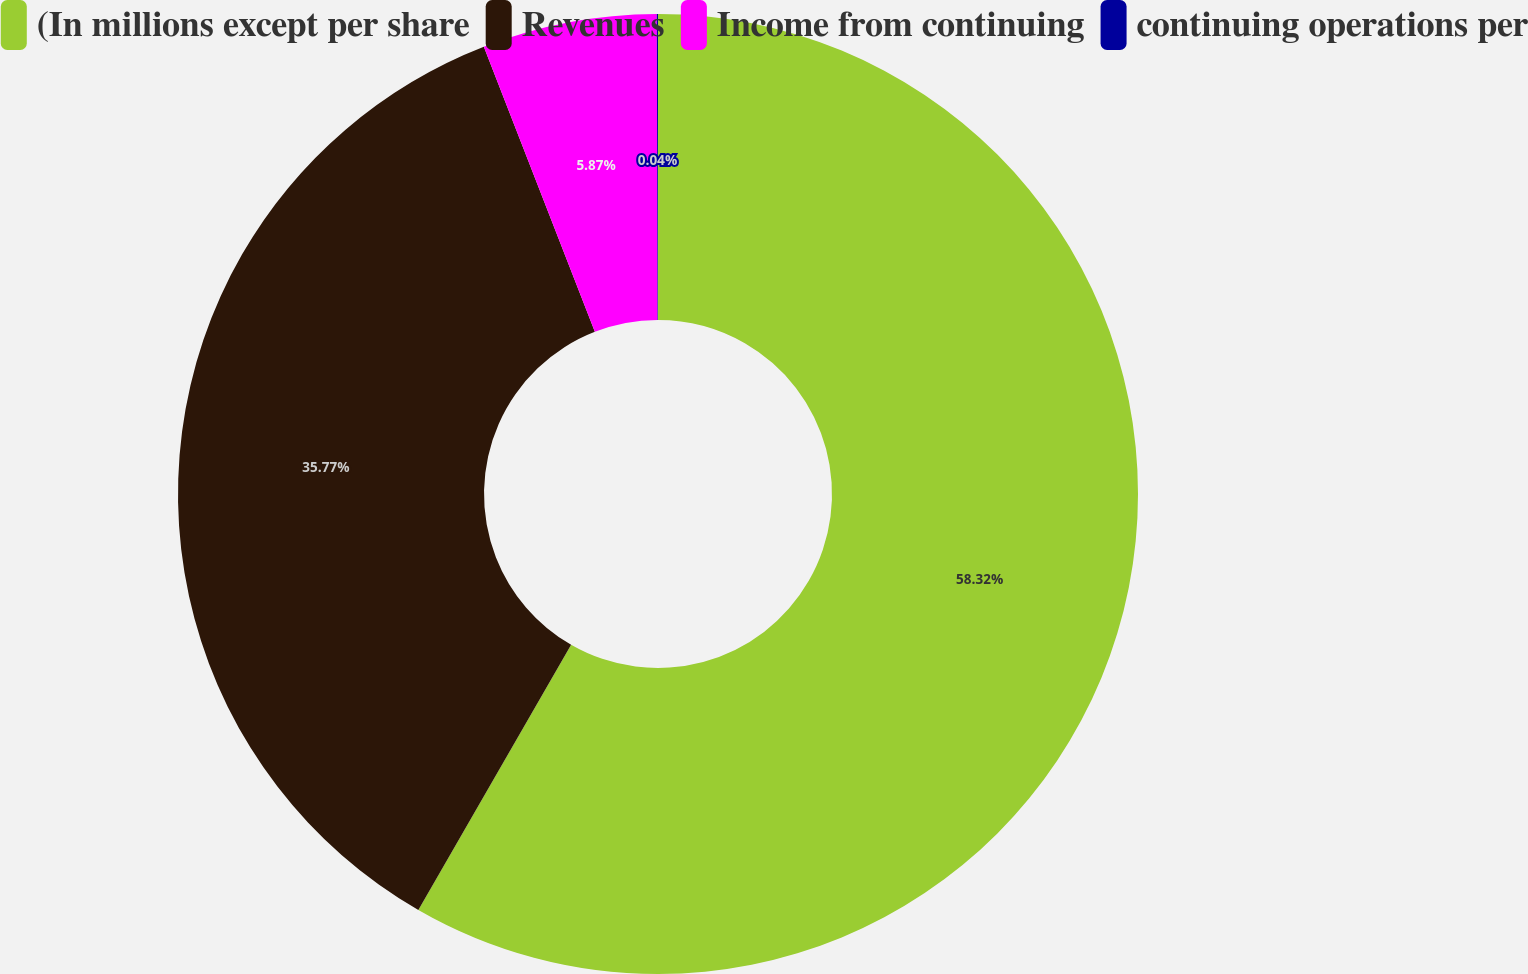Convert chart to OTSL. <chart><loc_0><loc_0><loc_500><loc_500><pie_chart><fcel>(In millions except per share<fcel>Revenues<fcel>Income from continuing<fcel>continuing operations per<nl><fcel>58.32%<fcel>35.77%<fcel>5.87%<fcel>0.04%<nl></chart> 